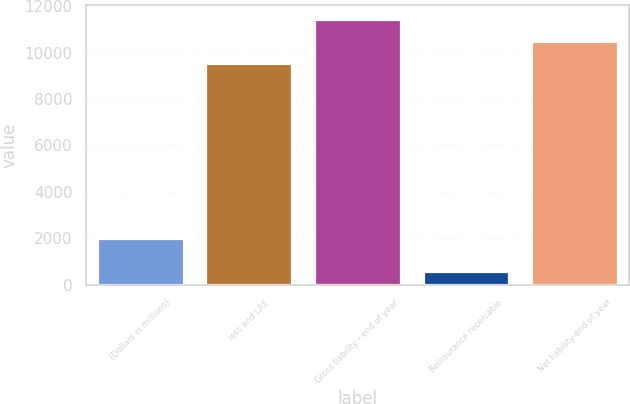Convert chart to OTSL. <chart><loc_0><loc_0><loc_500><loc_500><bar_chart><fcel>(Dollars in millions)<fcel>loss and LAE<fcel>Gross liability - end of year<fcel>Reinsurance receivable<fcel>Net liability-end of year<nl><fcel>2011<fcel>9553<fcel>11463.6<fcel>581.1<fcel>10508.3<nl></chart> 